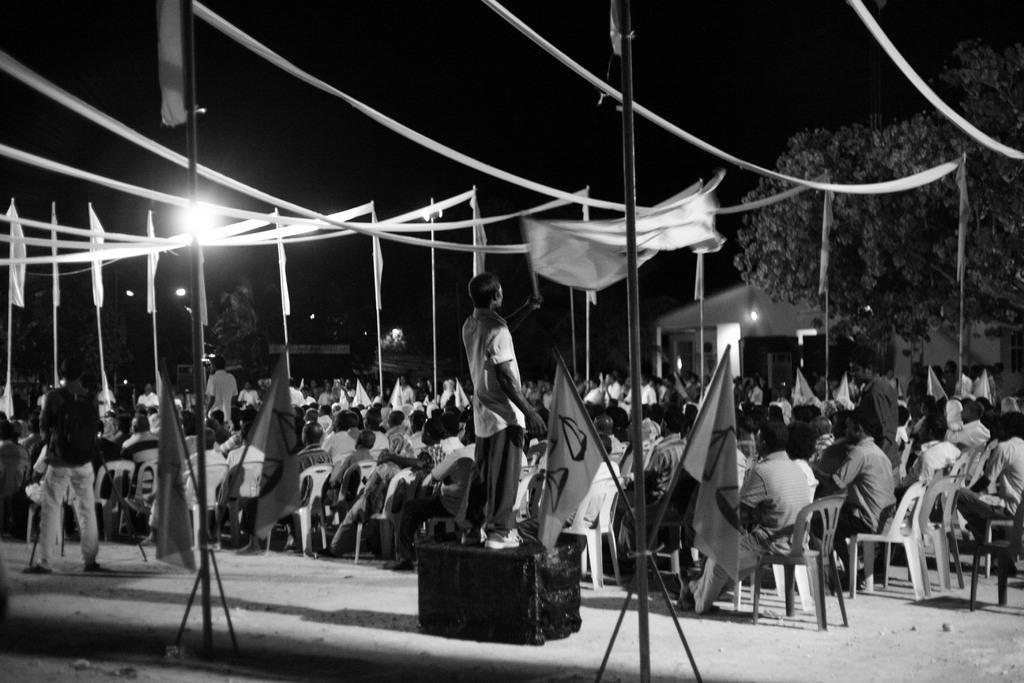In one or two sentences, can you explain what this image depicts? In this picture we can see flags and group of people, few are sitting on the chairs and few are standing, in the background we can see few lights and trees. 